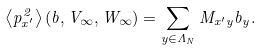<formula> <loc_0><loc_0><loc_500><loc_500>\left < p _ { x ^ { \prime } } ^ { 2 } \right > ( b , V _ { \infty } , W _ { \infty } ) = \sum _ { y \in \Lambda _ { N } } M _ { x ^ { \prime } y } b _ { y } .</formula> 